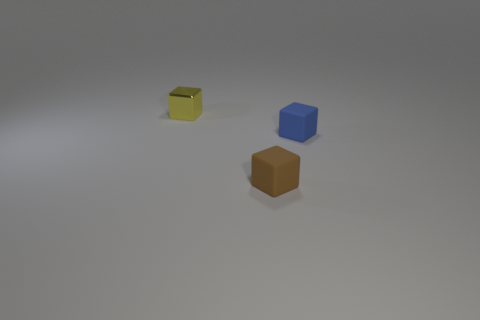Subtract all small metallic blocks. How many blocks are left? 2 Add 2 blue objects. How many objects exist? 5 Subtract all brown cubes. How many cubes are left? 2 Subtract all cyan cubes. Subtract all gray cylinders. How many cubes are left? 3 Subtract all big blue metal cylinders. Subtract all matte objects. How many objects are left? 1 Add 3 tiny objects. How many tiny objects are left? 6 Add 1 tiny brown objects. How many tiny brown objects exist? 2 Subtract 0 gray cylinders. How many objects are left? 3 